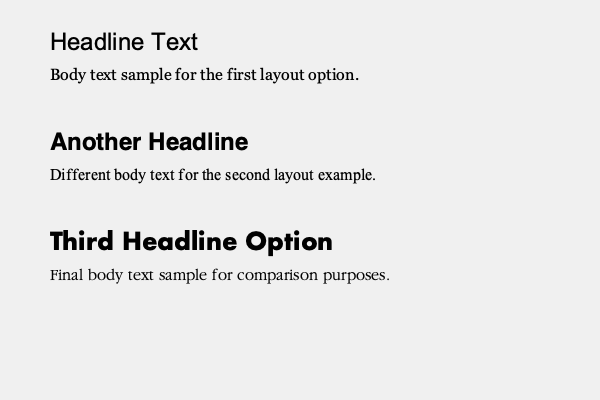As a graphic designer using Linux-based design software, which of the font pairings shown in the sample text layouts demonstrates the best contrast and readability for a professional design project? To determine the best font pairing for contrast and readability, we need to consider several factors:

1. Contrast between headline and body text:
   - Sample 1: Arial (sans-serif) with Georgia (serif)
   - Sample 2: Helvetica (sans-serif) with Times New Roman (serif)
   - Sample 3: Futura (sans-serif) with Garamond (serif)

2. Readability of body text:
   - Georgia is known for its excellent screen readability
   - Times New Roman is a classic serif font with good readability
   - Garamond is an elegant serif font with good readability, especially in print

3. Visual appeal and modern aesthetics:
   - Arial and Georgia offer a modern, clean look
   - Helvetica and Times New Roman are classic but may appear less contemporary
   - Futura and Garamond provide a balance of modern and traditional styles

4. Compatibility with Linux-based design software:
   - All fonts mentioned are widely supported and likely available in Linux systems

Considering these factors, the pairing of Futura and Garamond (Sample 3) offers the best combination of contrast, readability, and visual appeal. Futura is a geometric sans-serif font that provides a strong, modern look for headlines, while Garamond is an elegant serif font that ensures excellent readability for body text. This pairing creates a nice balance between contemporary and classic design elements, suitable for professional projects.
Answer: Futura (headline) and Garamond (body text) 